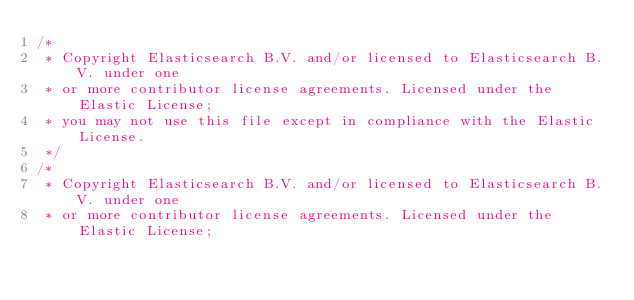<code> <loc_0><loc_0><loc_500><loc_500><_TypeScript_>/*
 * Copyright Elasticsearch B.V. and/or licensed to Elasticsearch B.V. under one
 * or more contributor license agreements. Licensed under the Elastic License;
 * you may not use this file except in compliance with the Elastic License.
 */
/*
 * Copyright Elasticsearch B.V. and/or licensed to Elasticsearch B.V. under one
 * or more contributor license agreements. Licensed under the Elastic License;</code> 